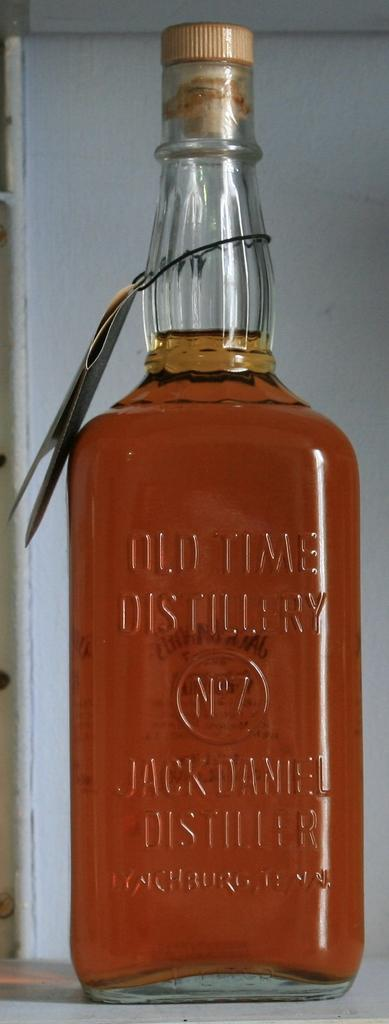What object is present in the image that contains a liquid? There is a glass bottle in the image that contains a liquid. What is the color of the liquid inside the bottle? The liquid is orange in color. What can be seen behind the bottle in the image? There is a white wall behind the bottle. How many beads are scattered around the bottle in the image? There are no beads present in the image; it only features a glass bottle with an orange liquid and a white wall as the background. 